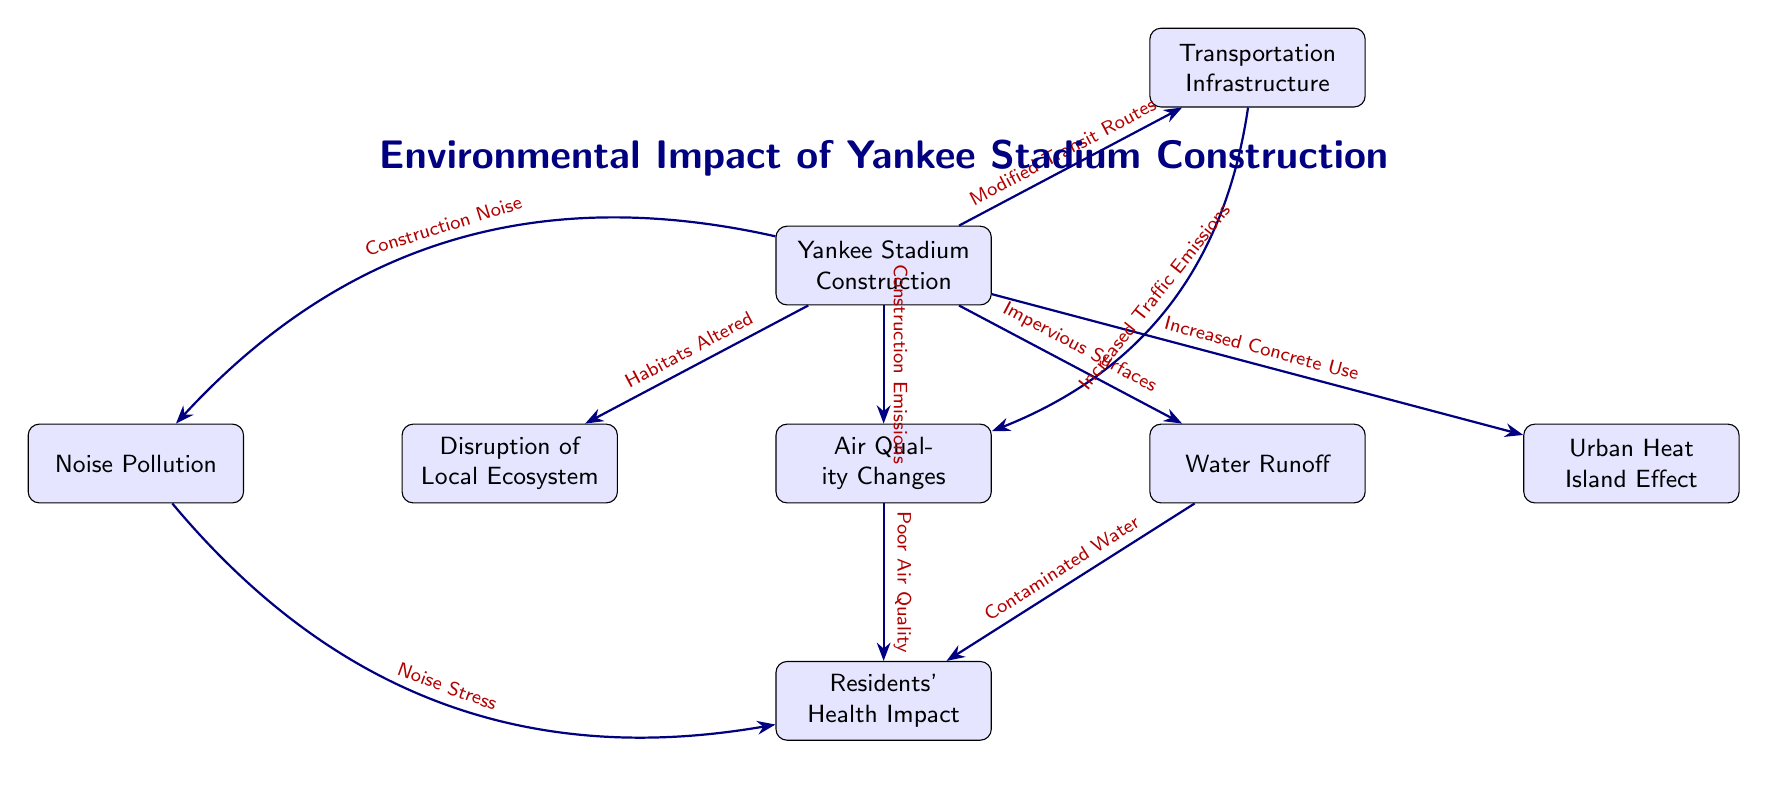What is the main focus of the diagram? The title of the diagram clearly states that the main focus is on the "Environmental Impact of Yankee Stadium Construction" which serves as the central theme for all subsequent relationships and effects depicted.
Answer: Environmental Impact of Yankee Stadium Construction How many main impacts of stadium construction are depicted in the diagram? There are six main impacts illustrated below the construction node, namely: Disruption of Local Ecosystem, Air Quality Changes, Water Runoff, Noise Pollution, Urban Heat Island Effect, and Residents' Health Impact.
Answer: Six Which element causes "Poor Air Quality"? The arrow labeled "Construction Emissions" connects the "Yankee Stadium Construction" node to the "Air Quality Changes" node, indicating this is the cause of poor air quality.
Answer: Construction Emissions What is indicated by the arrow from "Water Runoff" to "Residents' Health Impact"? The arrow indicates that there is a significant relationship where "Water Runoff" can lead to "Contaminated Water," which subsequently impacts the health of residents, demonstrating a connection between environmental changes and health issues.
Answer: Contaminated Water Which two factors contribute to "Residents' Health Impact"? The factors that contribute to "Residents' Health Impact" are "Contaminated Water," arising from "Water Runoff," and "Poor Air Quality," stemming from "Air Quality Changes." So both these factors have a direct role in affecting residents' health.
Answer: Contaminated Water and Poor Air Quality What effect from stadium construction leads to increased traffic emissions? The effect leading to increased traffic emissions is specified by the arrow from "Transportation Infrastructure," which indicates that changes in transit routes are linked to traffic emissions.
Answer: Modified Transit Routes Which type of pollution is associated with the "Noise Pollution" node? The "Noise Pollution" node is associated with "Construction Noise," as shown by the arrow that indicates construction activities generate noise pollution that may affect the surrounding community.
Answer: Construction Noise What is the relationship between "Increased Concrete Use" and the environment? "Increased Concrete Use" leads to the "Urban Heat Island Effect," as depicted by the arrow from the increased use of concrete to the environmental effect, illustrating the way construction materials can impact local climates.
Answer: Urban Heat Island Effect What is one of the effects of "Air Quality Changes"? One of the effects of "Air Quality Changes," as shown by the arrow connecting it to "Residents' Health Impact," is that it contributes to health issues experienced by residents.
Answer: Poor Air Quality 